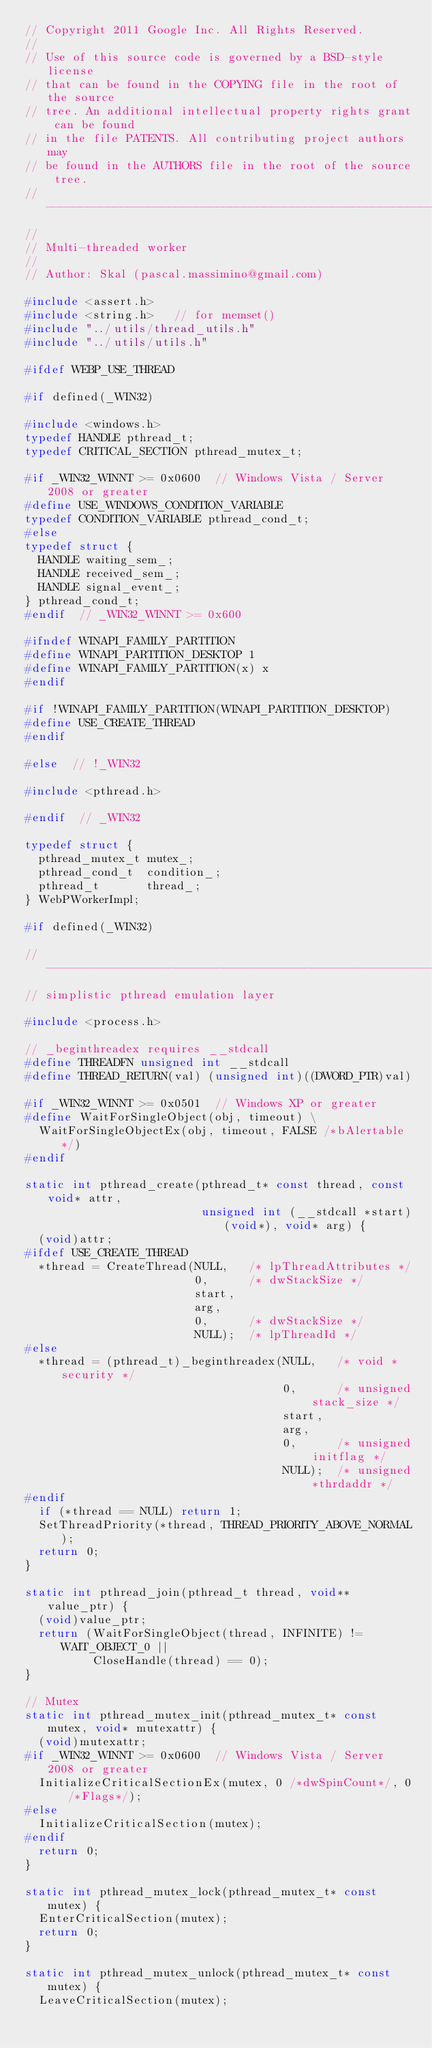<code> <loc_0><loc_0><loc_500><loc_500><_C_>// Copyright 2011 Google Inc. All Rights Reserved.
//
// Use of this source code is governed by a BSD-style license
// that can be found in the COPYING file in the root of the source
// tree. An additional intellectual property rights grant can be found
// in the file PATENTS. All contributing project authors may
// be found in the AUTHORS file in the root of the source tree.
// -----------------------------------------------------------------------------
//
// Multi-threaded worker
//
// Author: Skal (pascal.massimino@gmail.com)

#include <assert.h>
#include <string.h>   // for memset()
#include "../utils/thread_utils.h"
#include "../utils/utils.h"

#ifdef WEBP_USE_THREAD

#if defined(_WIN32)

#include <windows.h>
typedef HANDLE pthread_t;
typedef CRITICAL_SECTION pthread_mutex_t;

#if _WIN32_WINNT >= 0x0600  // Windows Vista / Server 2008 or greater
#define USE_WINDOWS_CONDITION_VARIABLE
typedef CONDITION_VARIABLE pthread_cond_t;
#else
typedef struct {
  HANDLE waiting_sem_;
  HANDLE received_sem_;
  HANDLE signal_event_;
} pthread_cond_t;
#endif  // _WIN32_WINNT >= 0x600

#ifndef WINAPI_FAMILY_PARTITION
#define WINAPI_PARTITION_DESKTOP 1
#define WINAPI_FAMILY_PARTITION(x) x
#endif

#if !WINAPI_FAMILY_PARTITION(WINAPI_PARTITION_DESKTOP)
#define USE_CREATE_THREAD
#endif

#else  // !_WIN32

#include <pthread.h>

#endif  // _WIN32

typedef struct {
  pthread_mutex_t mutex_;
  pthread_cond_t  condition_;
  pthread_t       thread_;
} WebPWorkerImpl;

#if defined(_WIN32)

//------------------------------------------------------------------------------
// simplistic pthread emulation layer

#include <process.h>

// _beginthreadex requires __stdcall
#define THREADFN unsigned int __stdcall
#define THREAD_RETURN(val) (unsigned int)((DWORD_PTR)val)

#if _WIN32_WINNT >= 0x0501  // Windows XP or greater
#define WaitForSingleObject(obj, timeout) \
  WaitForSingleObjectEx(obj, timeout, FALSE /*bAlertable*/)
#endif

static int pthread_create(pthread_t* const thread, const void* attr,
                          unsigned int (__stdcall *start)(void*), void* arg) {
  (void)attr;
#ifdef USE_CREATE_THREAD
  *thread = CreateThread(NULL,   /* lpThreadAttributes */
                         0,      /* dwStackSize */
                         start,
                         arg,
                         0,      /* dwStackSize */
                         NULL);  /* lpThreadId */
#else
  *thread = (pthread_t)_beginthreadex(NULL,   /* void *security */
                                      0,      /* unsigned stack_size */
                                      start,
                                      arg,
                                      0,      /* unsigned initflag */
                                      NULL);  /* unsigned *thrdaddr */
#endif
  if (*thread == NULL) return 1;
  SetThreadPriority(*thread, THREAD_PRIORITY_ABOVE_NORMAL);
  return 0;
}

static int pthread_join(pthread_t thread, void** value_ptr) {
  (void)value_ptr;
  return (WaitForSingleObject(thread, INFINITE) != WAIT_OBJECT_0 ||
          CloseHandle(thread) == 0);
}

// Mutex
static int pthread_mutex_init(pthread_mutex_t* const mutex, void* mutexattr) {
  (void)mutexattr;
#if _WIN32_WINNT >= 0x0600  // Windows Vista / Server 2008 or greater
  InitializeCriticalSectionEx(mutex, 0 /*dwSpinCount*/, 0 /*Flags*/);
#else
  InitializeCriticalSection(mutex);
#endif
  return 0;
}

static int pthread_mutex_lock(pthread_mutex_t* const mutex) {
  EnterCriticalSection(mutex);
  return 0;
}

static int pthread_mutex_unlock(pthread_mutex_t* const mutex) {
  LeaveCriticalSection(mutex);</code> 